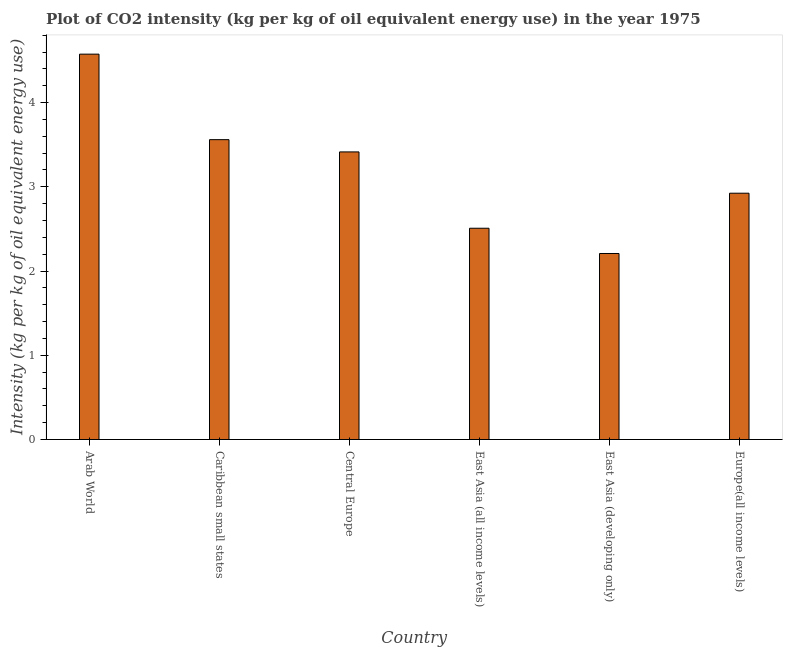What is the title of the graph?
Ensure brevity in your answer.  Plot of CO2 intensity (kg per kg of oil equivalent energy use) in the year 1975. What is the label or title of the X-axis?
Your answer should be compact. Country. What is the label or title of the Y-axis?
Provide a short and direct response. Intensity (kg per kg of oil equivalent energy use). What is the co2 intensity in Caribbean small states?
Keep it short and to the point. 3.56. Across all countries, what is the maximum co2 intensity?
Offer a terse response. 4.57. Across all countries, what is the minimum co2 intensity?
Give a very brief answer. 2.21. In which country was the co2 intensity maximum?
Ensure brevity in your answer.  Arab World. In which country was the co2 intensity minimum?
Provide a succinct answer. East Asia (developing only). What is the sum of the co2 intensity?
Give a very brief answer. 19.19. What is the difference between the co2 intensity in Central Europe and East Asia (all income levels)?
Offer a terse response. 0.91. What is the average co2 intensity per country?
Your answer should be compact. 3.2. What is the median co2 intensity?
Your response must be concise. 3.17. What is the ratio of the co2 intensity in Caribbean small states to that in Central Europe?
Provide a succinct answer. 1.04. Is the difference between the co2 intensity in East Asia (all income levels) and Europe(all income levels) greater than the difference between any two countries?
Your answer should be compact. No. What is the difference between the highest and the second highest co2 intensity?
Ensure brevity in your answer.  1.01. Is the sum of the co2 intensity in Arab World and Europe(all income levels) greater than the maximum co2 intensity across all countries?
Your response must be concise. Yes. What is the difference between the highest and the lowest co2 intensity?
Your response must be concise. 2.37. In how many countries, is the co2 intensity greater than the average co2 intensity taken over all countries?
Your answer should be very brief. 3. How many bars are there?
Ensure brevity in your answer.  6. Are all the bars in the graph horizontal?
Give a very brief answer. No. How many countries are there in the graph?
Provide a short and direct response. 6. What is the difference between two consecutive major ticks on the Y-axis?
Keep it short and to the point. 1. Are the values on the major ticks of Y-axis written in scientific E-notation?
Your response must be concise. No. What is the Intensity (kg per kg of oil equivalent energy use) of Arab World?
Provide a short and direct response. 4.57. What is the Intensity (kg per kg of oil equivalent energy use) of Caribbean small states?
Keep it short and to the point. 3.56. What is the Intensity (kg per kg of oil equivalent energy use) of Central Europe?
Give a very brief answer. 3.41. What is the Intensity (kg per kg of oil equivalent energy use) of East Asia (all income levels)?
Provide a short and direct response. 2.51. What is the Intensity (kg per kg of oil equivalent energy use) of East Asia (developing only)?
Give a very brief answer. 2.21. What is the Intensity (kg per kg of oil equivalent energy use) of Europe(all income levels)?
Your response must be concise. 2.92. What is the difference between the Intensity (kg per kg of oil equivalent energy use) in Arab World and Caribbean small states?
Make the answer very short. 1.02. What is the difference between the Intensity (kg per kg of oil equivalent energy use) in Arab World and Central Europe?
Provide a succinct answer. 1.16. What is the difference between the Intensity (kg per kg of oil equivalent energy use) in Arab World and East Asia (all income levels)?
Your answer should be very brief. 2.07. What is the difference between the Intensity (kg per kg of oil equivalent energy use) in Arab World and East Asia (developing only)?
Ensure brevity in your answer.  2.37. What is the difference between the Intensity (kg per kg of oil equivalent energy use) in Arab World and Europe(all income levels)?
Your answer should be compact. 1.65. What is the difference between the Intensity (kg per kg of oil equivalent energy use) in Caribbean small states and Central Europe?
Your response must be concise. 0.15. What is the difference between the Intensity (kg per kg of oil equivalent energy use) in Caribbean small states and East Asia (all income levels)?
Your response must be concise. 1.05. What is the difference between the Intensity (kg per kg of oil equivalent energy use) in Caribbean small states and East Asia (developing only)?
Make the answer very short. 1.35. What is the difference between the Intensity (kg per kg of oil equivalent energy use) in Caribbean small states and Europe(all income levels)?
Provide a short and direct response. 0.64. What is the difference between the Intensity (kg per kg of oil equivalent energy use) in Central Europe and East Asia (all income levels)?
Your answer should be compact. 0.91. What is the difference between the Intensity (kg per kg of oil equivalent energy use) in Central Europe and East Asia (developing only)?
Make the answer very short. 1.21. What is the difference between the Intensity (kg per kg of oil equivalent energy use) in Central Europe and Europe(all income levels)?
Provide a succinct answer. 0.49. What is the difference between the Intensity (kg per kg of oil equivalent energy use) in East Asia (all income levels) and East Asia (developing only)?
Your answer should be very brief. 0.3. What is the difference between the Intensity (kg per kg of oil equivalent energy use) in East Asia (all income levels) and Europe(all income levels)?
Give a very brief answer. -0.42. What is the difference between the Intensity (kg per kg of oil equivalent energy use) in East Asia (developing only) and Europe(all income levels)?
Your answer should be very brief. -0.72. What is the ratio of the Intensity (kg per kg of oil equivalent energy use) in Arab World to that in Caribbean small states?
Your answer should be compact. 1.28. What is the ratio of the Intensity (kg per kg of oil equivalent energy use) in Arab World to that in Central Europe?
Make the answer very short. 1.34. What is the ratio of the Intensity (kg per kg of oil equivalent energy use) in Arab World to that in East Asia (all income levels)?
Provide a short and direct response. 1.82. What is the ratio of the Intensity (kg per kg of oil equivalent energy use) in Arab World to that in East Asia (developing only)?
Offer a very short reply. 2.07. What is the ratio of the Intensity (kg per kg of oil equivalent energy use) in Arab World to that in Europe(all income levels)?
Provide a succinct answer. 1.56. What is the ratio of the Intensity (kg per kg of oil equivalent energy use) in Caribbean small states to that in Central Europe?
Give a very brief answer. 1.04. What is the ratio of the Intensity (kg per kg of oil equivalent energy use) in Caribbean small states to that in East Asia (all income levels)?
Provide a short and direct response. 1.42. What is the ratio of the Intensity (kg per kg of oil equivalent energy use) in Caribbean small states to that in East Asia (developing only)?
Your answer should be compact. 1.61. What is the ratio of the Intensity (kg per kg of oil equivalent energy use) in Caribbean small states to that in Europe(all income levels)?
Offer a very short reply. 1.22. What is the ratio of the Intensity (kg per kg of oil equivalent energy use) in Central Europe to that in East Asia (all income levels)?
Keep it short and to the point. 1.36. What is the ratio of the Intensity (kg per kg of oil equivalent energy use) in Central Europe to that in East Asia (developing only)?
Your answer should be compact. 1.55. What is the ratio of the Intensity (kg per kg of oil equivalent energy use) in Central Europe to that in Europe(all income levels)?
Provide a short and direct response. 1.17. What is the ratio of the Intensity (kg per kg of oil equivalent energy use) in East Asia (all income levels) to that in East Asia (developing only)?
Provide a short and direct response. 1.14. What is the ratio of the Intensity (kg per kg of oil equivalent energy use) in East Asia (all income levels) to that in Europe(all income levels)?
Your answer should be very brief. 0.86. What is the ratio of the Intensity (kg per kg of oil equivalent energy use) in East Asia (developing only) to that in Europe(all income levels)?
Offer a terse response. 0.76. 